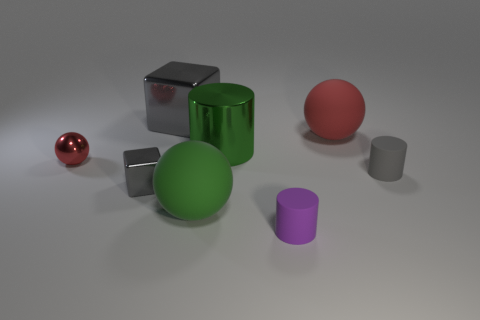The green ball that is the same material as the big red sphere is what size?
Offer a very short reply. Large. Is there any other thing that is the same color as the big cube?
Ensure brevity in your answer.  Yes. Does the shiny thing on the right side of the big block have the same color as the tiny cube that is behind the purple rubber cylinder?
Make the answer very short. No. What is the color of the large thing that is on the right side of the big green cylinder?
Provide a short and direct response. Red. Does the red sphere on the left side of the red rubber thing have the same size as the small purple cylinder?
Keep it short and to the point. Yes. Is the number of big red rubber spheres less than the number of tiny matte objects?
Make the answer very short. Yes. The big thing that is the same color as the large cylinder is what shape?
Your response must be concise. Sphere. There is a small sphere; how many big red rubber things are in front of it?
Offer a terse response. 0. Is the green matte thing the same shape as the big green metal thing?
Offer a very short reply. No. What number of gray objects are both behind the small red metal thing and right of the green rubber thing?
Give a very brief answer. 0. 